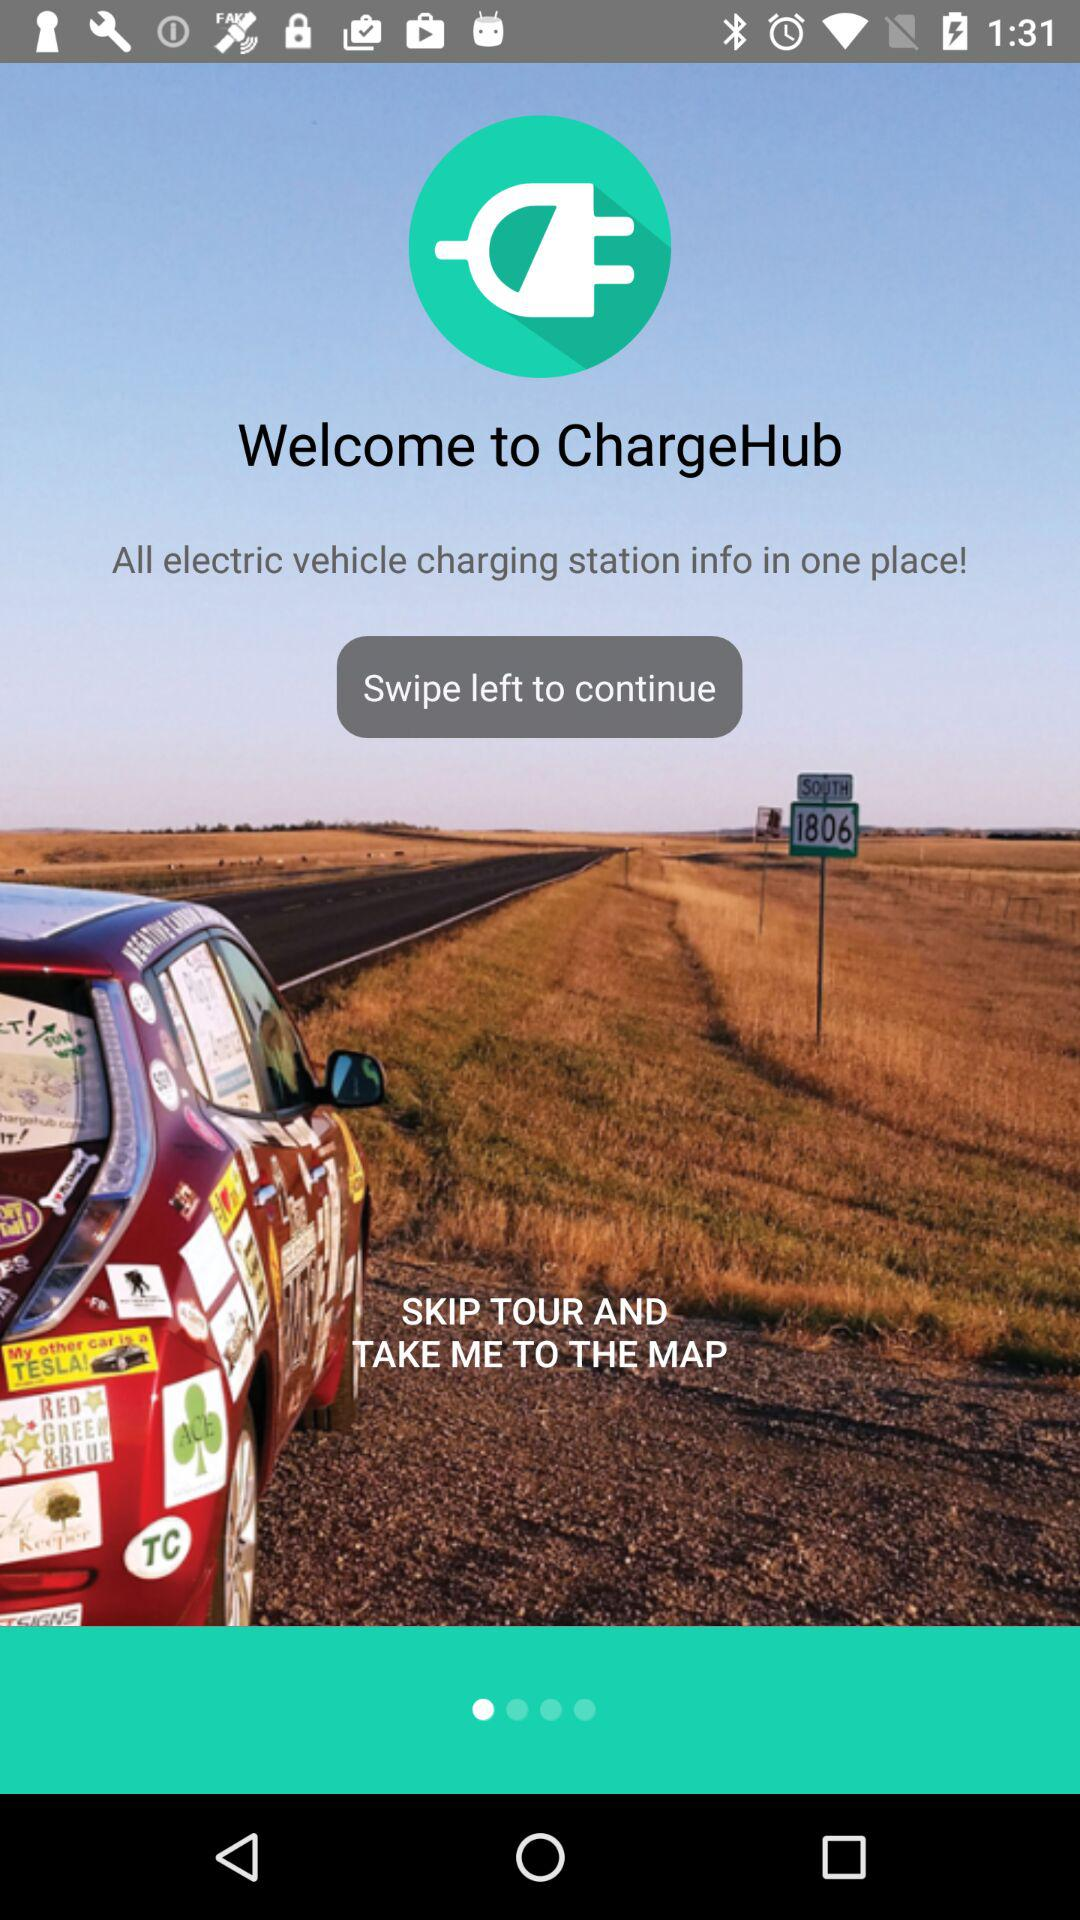What is the name of the application? The application name is "ChargeHub". 